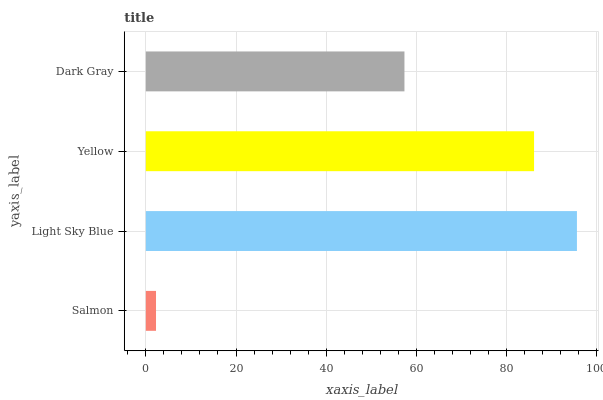Is Salmon the minimum?
Answer yes or no. Yes. Is Light Sky Blue the maximum?
Answer yes or no. Yes. Is Yellow the minimum?
Answer yes or no. No. Is Yellow the maximum?
Answer yes or no. No. Is Light Sky Blue greater than Yellow?
Answer yes or no. Yes. Is Yellow less than Light Sky Blue?
Answer yes or no. Yes. Is Yellow greater than Light Sky Blue?
Answer yes or no. No. Is Light Sky Blue less than Yellow?
Answer yes or no. No. Is Yellow the high median?
Answer yes or no. Yes. Is Dark Gray the low median?
Answer yes or no. Yes. Is Dark Gray the high median?
Answer yes or no. No. Is Salmon the low median?
Answer yes or no. No. 